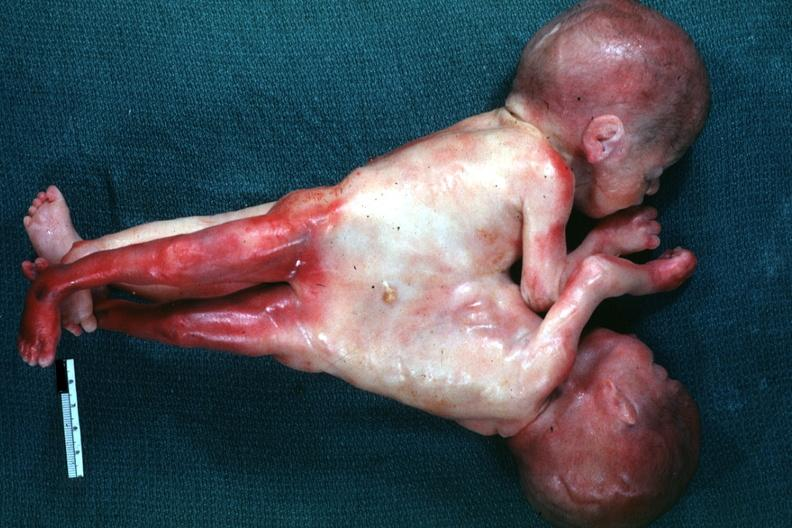s lateral view joined at chest and abdomen?
Answer the question using a single word or phrase. Yes 